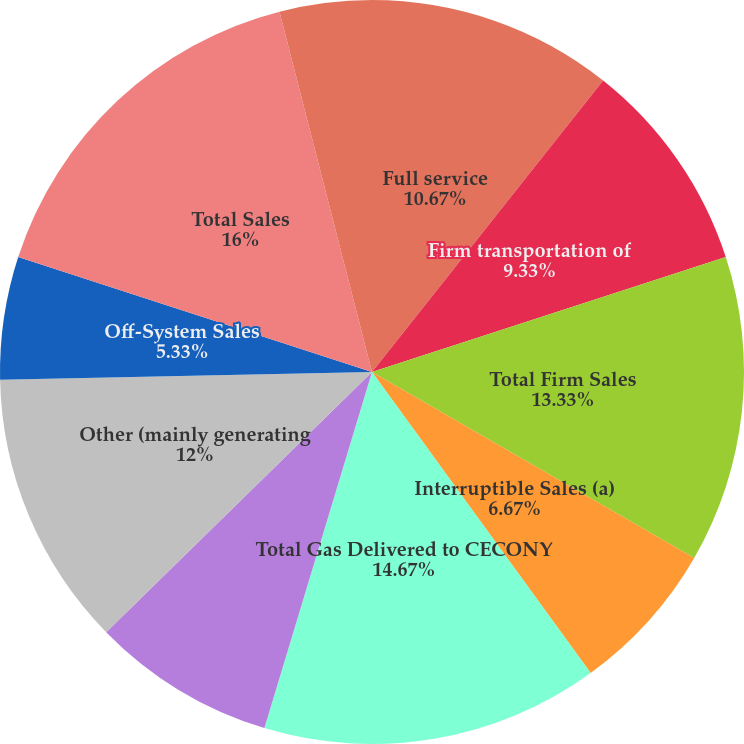<chart> <loc_0><loc_0><loc_500><loc_500><pie_chart><fcel>Full service<fcel>Firm transportation of<fcel>Total Firm Sales<fcel>Interruptible Sales (a)<fcel>Total Gas Delivered to CECONY<fcel>NYPA<fcel>Other (mainly generating<fcel>Off-System Sales<fcel>Total Sales<fcel>Interruptible Sales<nl><fcel>10.67%<fcel>9.33%<fcel>13.33%<fcel>6.67%<fcel>14.67%<fcel>8.0%<fcel>12.0%<fcel>5.33%<fcel>16.0%<fcel>4.0%<nl></chart> 